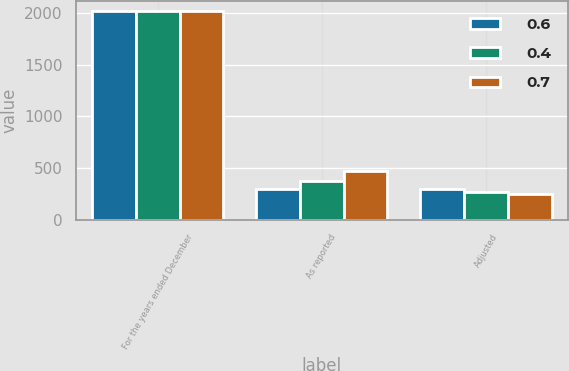Convert chart to OTSL. <chart><loc_0><loc_0><loc_500><loc_500><stacked_bar_chart><ecel><fcel>For the years ended December<fcel>As reported<fcel>Adjusted<nl><fcel>0.6<fcel>2015<fcel>299.3<fcel>294.1<nl><fcel>0.4<fcel>2014<fcel>375.8<fcel>272.6<nl><fcel>0.7<fcel>2013<fcel>471.7<fcel>244.9<nl></chart> 